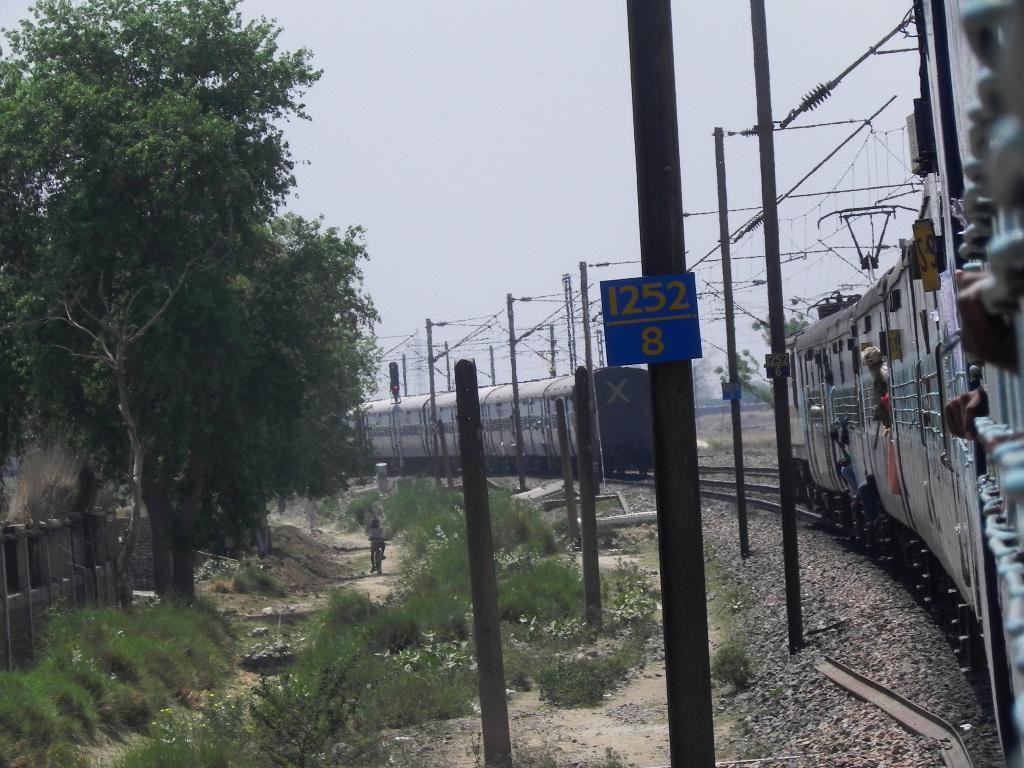Can you describe this image briefly? In this image we can see trains on the railway track, electric cables, poles, shrubs, person riding bicycle, trees, wooden fence and sky. 